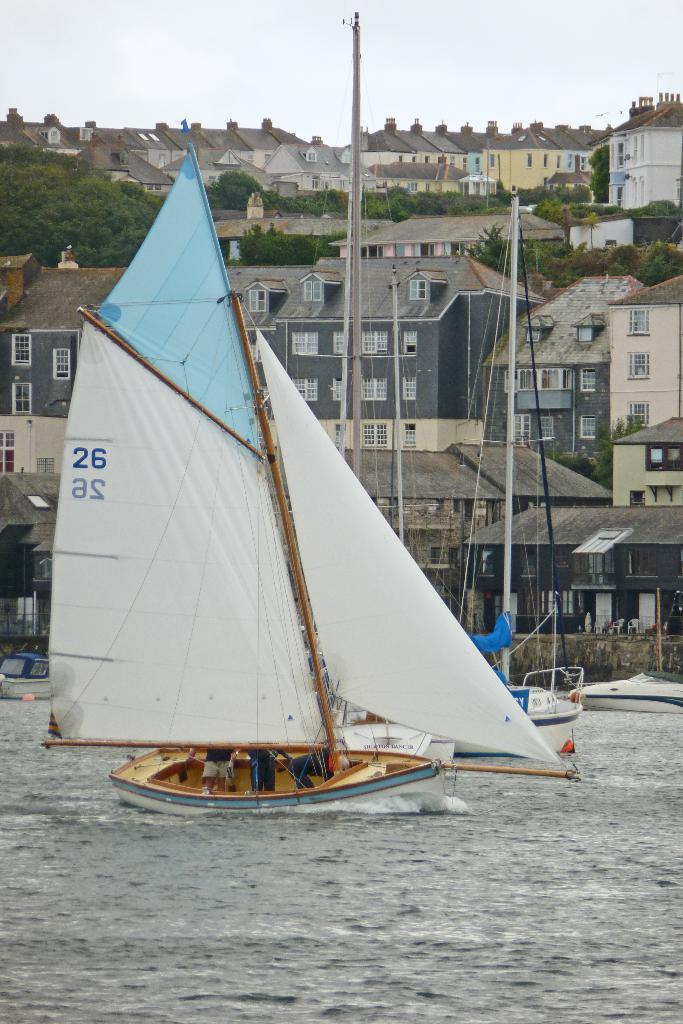What are the people doing in the image? The people are on a boat in the image. Where is the boat located? The boat is on the water. What can be seen in the background of the image? There are buildings, trees, and the sky visible in the background of the image. What type of hook is being used by the people on the boat to catch fish in the image? There is no hook visible in the image, and the people on the boat are not shown catching fish. 